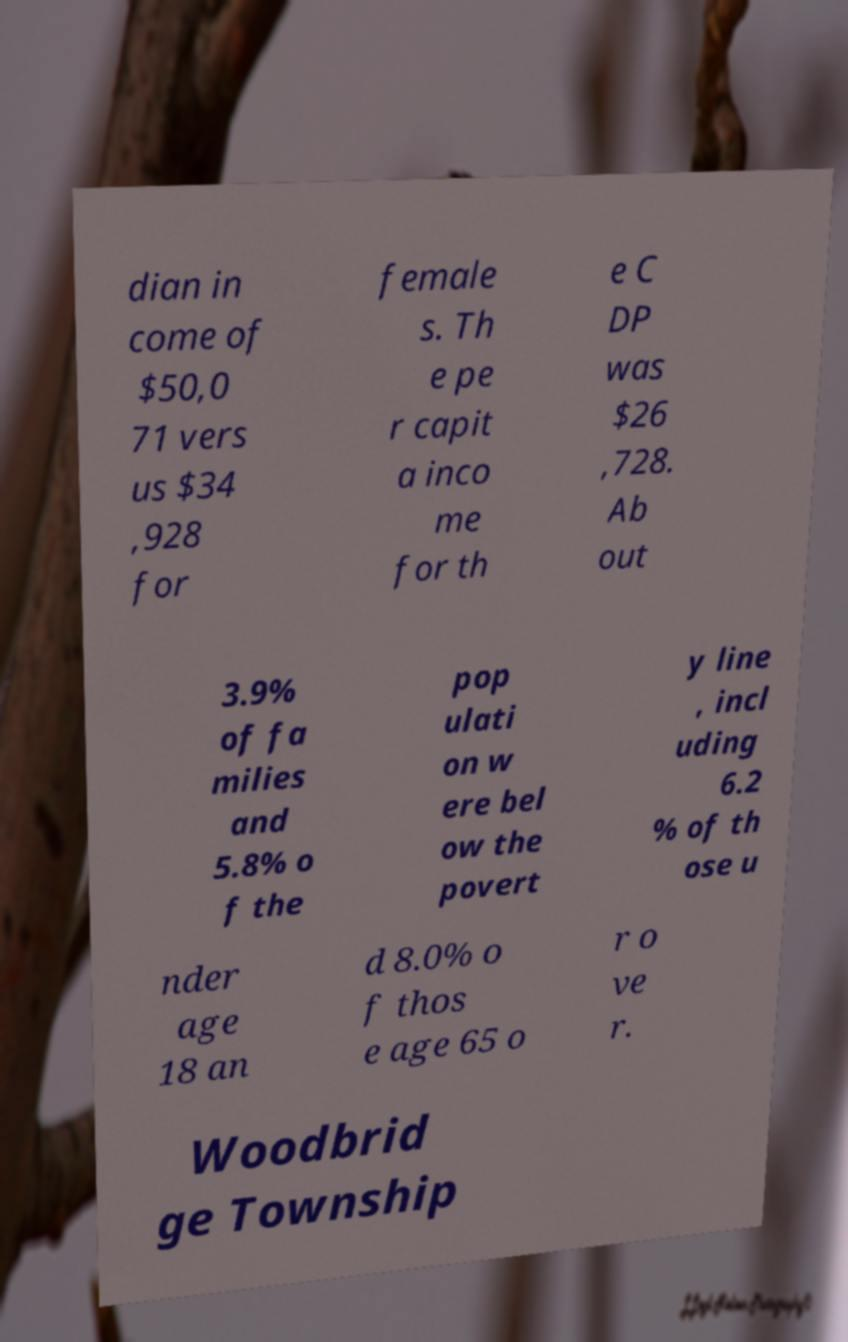Could you extract and type out the text from this image? dian in come of $50,0 71 vers us $34 ,928 for female s. Th e pe r capit a inco me for th e C DP was $26 ,728. Ab out 3.9% of fa milies and 5.8% o f the pop ulati on w ere bel ow the povert y line , incl uding 6.2 % of th ose u nder age 18 an d 8.0% o f thos e age 65 o r o ve r. Woodbrid ge Township 